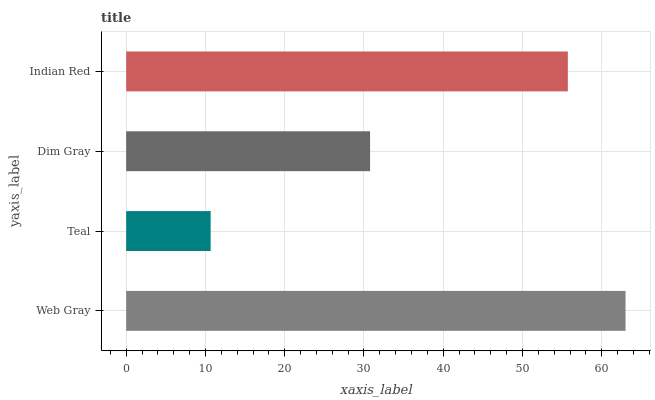Is Teal the minimum?
Answer yes or no. Yes. Is Web Gray the maximum?
Answer yes or no. Yes. Is Dim Gray the minimum?
Answer yes or no. No. Is Dim Gray the maximum?
Answer yes or no. No. Is Dim Gray greater than Teal?
Answer yes or no. Yes. Is Teal less than Dim Gray?
Answer yes or no. Yes. Is Teal greater than Dim Gray?
Answer yes or no. No. Is Dim Gray less than Teal?
Answer yes or no. No. Is Indian Red the high median?
Answer yes or no. Yes. Is Dim Gray the low median?
Answer yes or no. Yes. Is Dim Gray the high median?
Answer yes or no. No. Is Teal the low median?
Answer yes or no. No. 